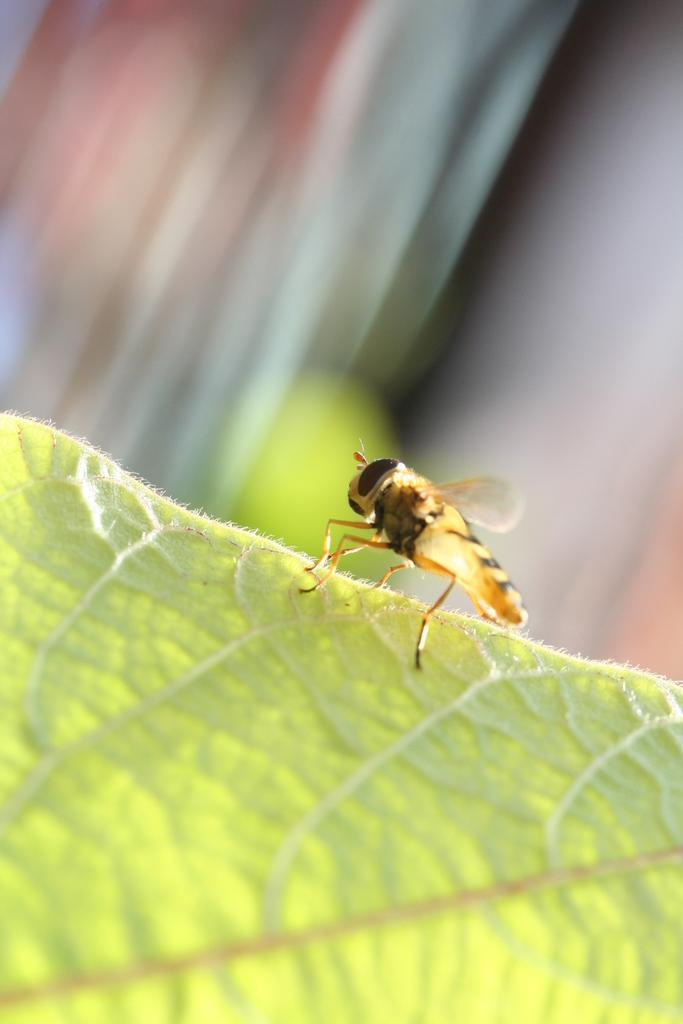What type of creature is in the image? There is an insect in the image. What colors can be seen on the insect? The insect has yellow and black coloring. Where is the insect located in the image? The insect is on a green leaf. How would you describe the background of the image? The background of the image is blurred. What type of soap is being used by the army in the image? There is no soap or army present in the image; it features an insect on a green leaf with a blurred background. 